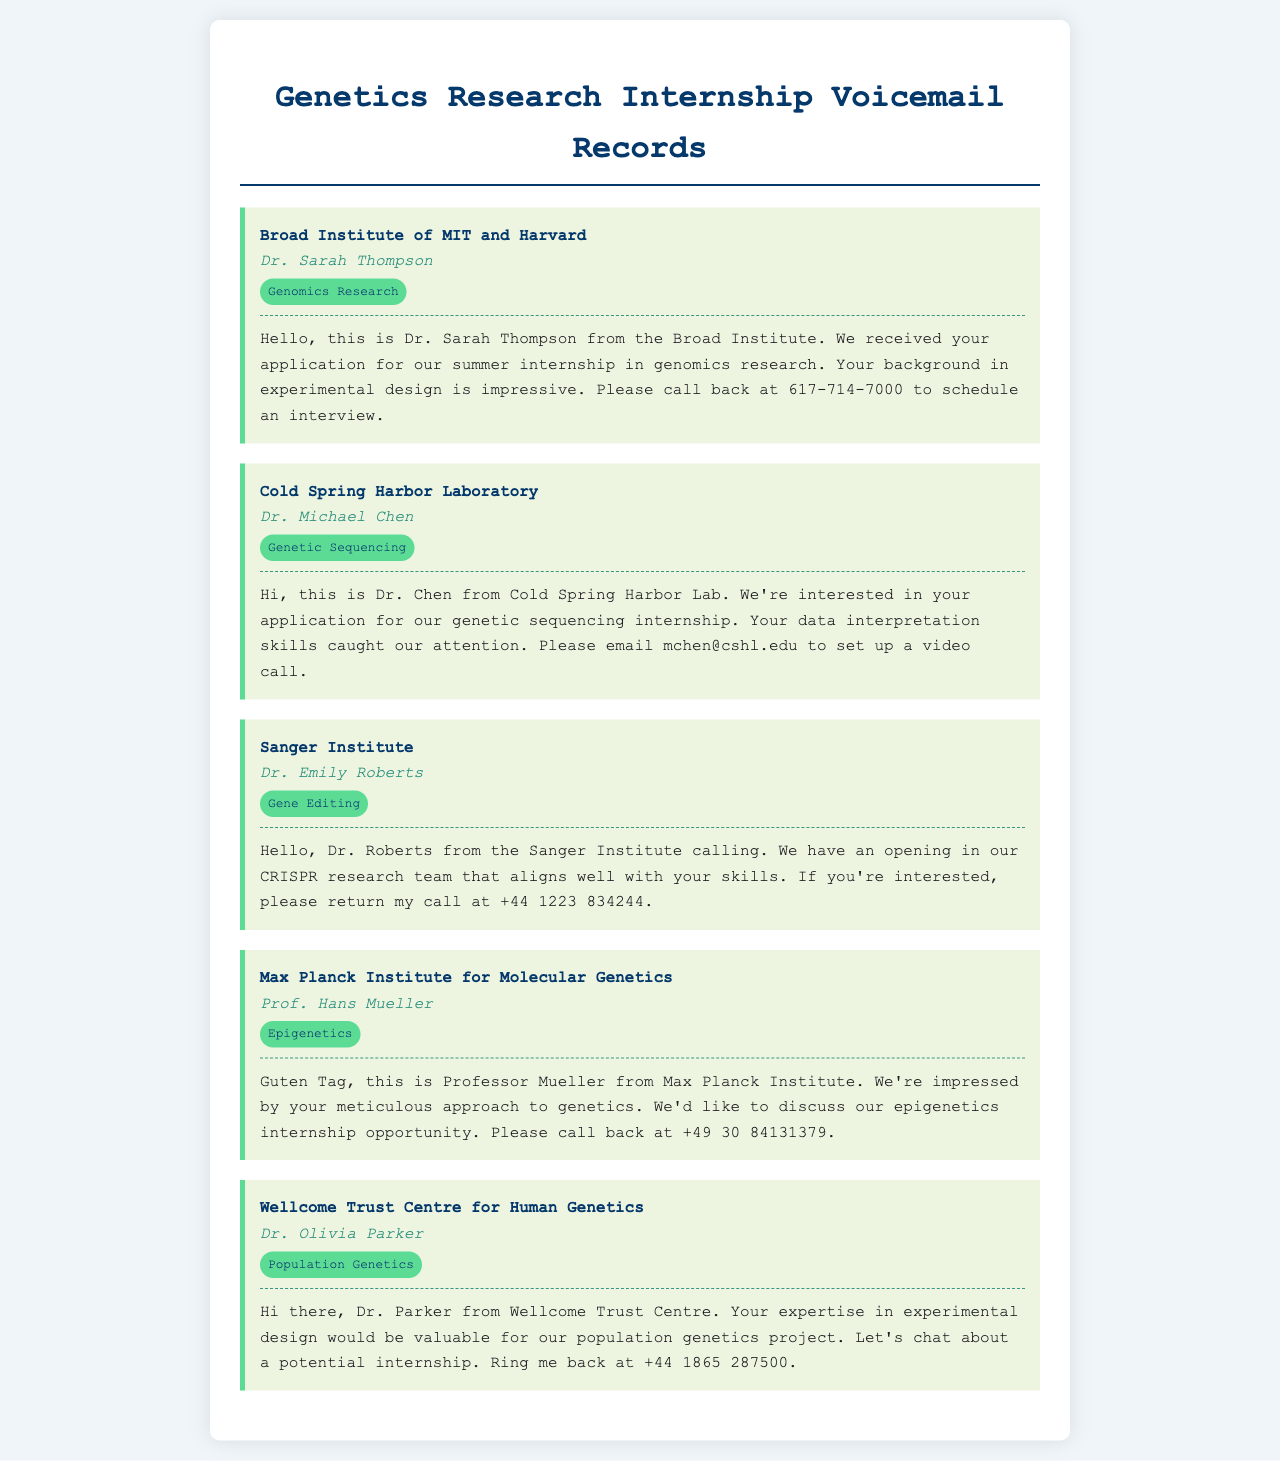What is the name of the institution for the genomic research internship? The document states the institution is the Broad Institute of MIT and Harvard.
Answer: Broad Institute of MIT and Harvard Who is the contact person at Cold Spring Harbor Laboratory? The voicemail identifies Dr. Michael Chen as the contact for this institution.
Answer: Dr. Michael Chen What is the category of the internship opportunity at the Sanger Institute? The document indicates that the category is Gene Editing.
Answer: Gene Editing What is the contact number for the Max Planck Institute for Molecular Genetics? The voicemail specifies the contact number as +49 30 84131379.
Answer: +49 30 84131379 What type of internship is mentioned in the voicemail from Wellcome Trust Centre for Human Genetics? The document describes the internship type as Population Genetics.
Answer: Population Genetics Why is the Broad Institute interested in the applicant? The voicemail highlights the applicant's impressive background in experimental design.
Answer: Impressive background in experimental design Which research team is mentioned in relation to the Sanger Institute? The voicemail refers to the CRISPR research team in the context of the internship opportunity.
Answer: CRISPR research team How should a candidate contact Dr. Olivia Parker for the internship? The document provides a specific instruction to ring her back at the provided number.
Answer: Ring me back at +44 1865 287500 What skill set attracted Cold Spring Harbor Laboratory to the applicant? The voicemail mentions the applicant's data interpretation skills as a point of interest.
Answer: Data interpretation skills 